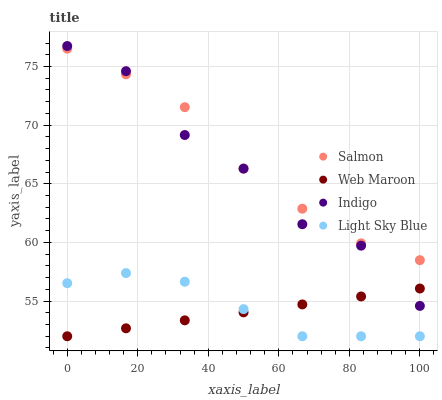Does Web Maroon have the minimum area under the curve?
Answer yes or no. Yes. Does Salmon have the maximum area under the curve?
Answer yes or no. Yes. Does Light Sky Blue have the minimum area under the curve?
Answer yes or no. No. Does Light Sky Blue have the maximum area under the curve?
Answer yes or no. No. Is Web Maroon the smoothest?
Answer yes or no. Yes. Is Indigo the roughest?
Answer yes or no. Yes. Is Light Sky Blue the smoothest?
Answer yes or no. No. Is Light Sky Blue the roughest?
Answer yes or no. No. Does Web Maroon have the lowest value?
Answer yes or no. Yes. Does Salmon have the lowest value?
Answer yes or no. No. Does Indigo have the highest value?
Answer yes or no. Yes. Does Light Sky Blue have the highest value?
Answer yes or no. No. Is Light Sky Blue less than Salmon?
Answer yes or no. Yes. Is Indigo greater than Light Sky Blue?
Answer yes or no. Yes. Does Web Maroon intersect Light Sky Blue?
Answer yes or no. Yes. Is Web Maroon less than Light Sky Blue?
Answer yes or no. No. Is Web Maroon greater than Light Sky Blue?
Answer yes or no. No. Does Light Sky Blue intersect Salmon?
Answer yes or no. No. 